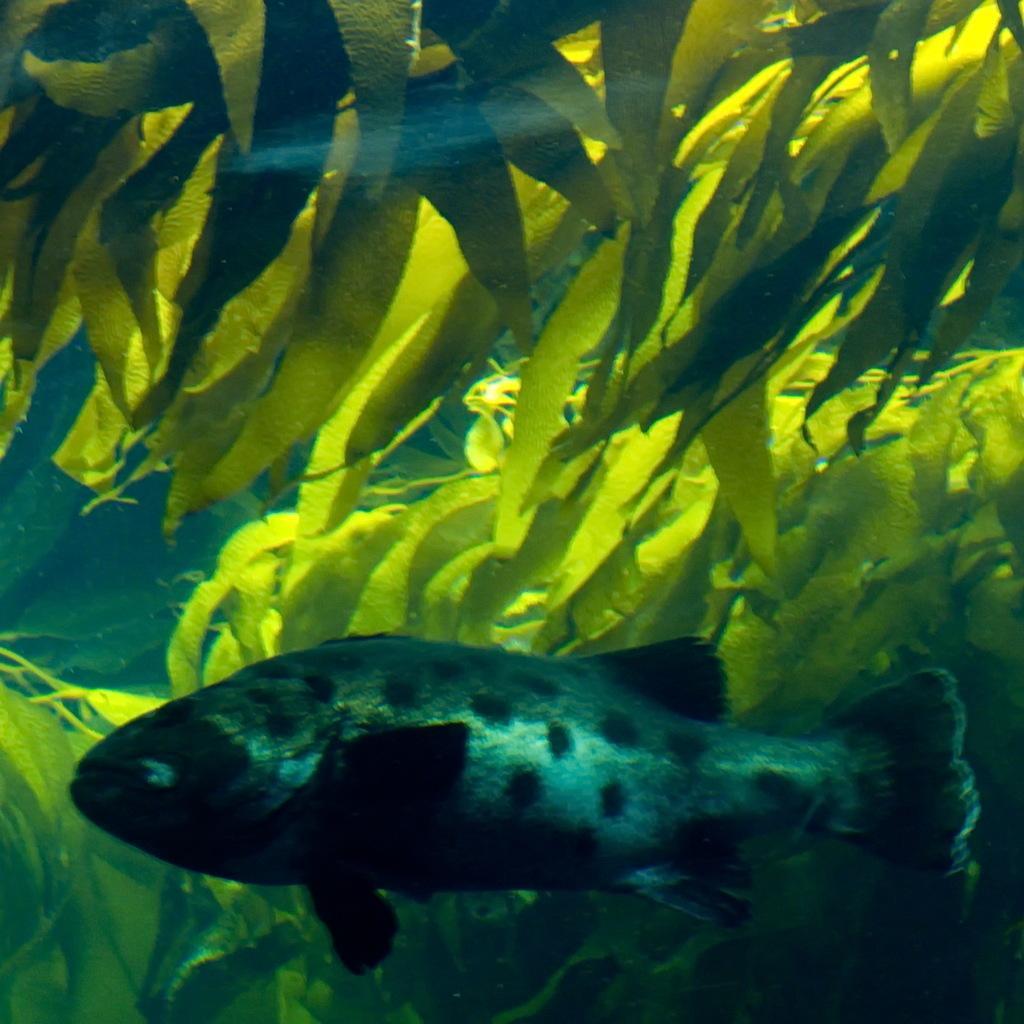Can you describe this image briefly? In this image we can see many plants. There is a fish in the water. 